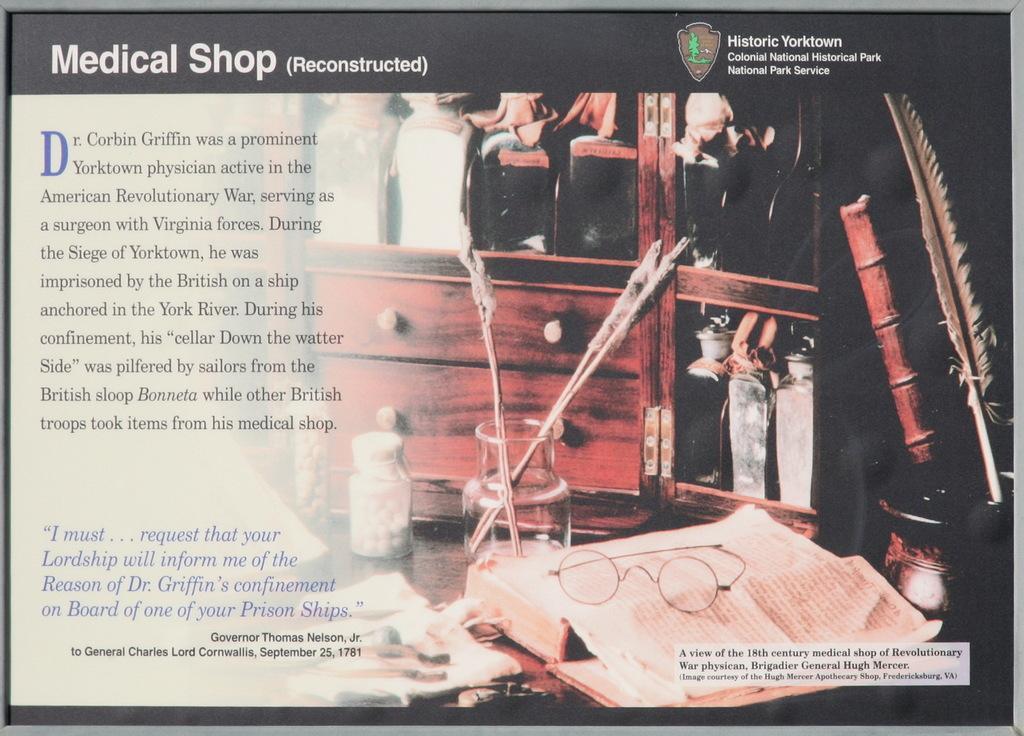How would you summarize this image in a sentence or two? This image consists of a board or a frame. In which, we can see a book along with spectacles. And there are drawers and cupboards. On the right, there is an ink pot. On the left, there is a text. In the middle, there is a jar. 